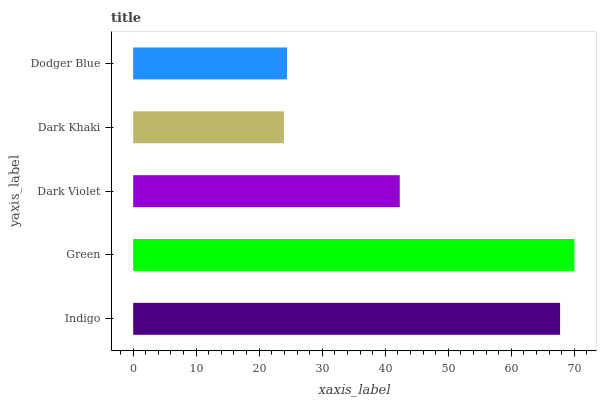Is Dark Khaki the minimum?
Answer yes or no. Yes. Is Green the maximum?
Answer yes or no. Yes. Is Dark Violet the minimum?
Answer yes or no. No. Is Dark Violet the maximum?
Answer yes or no. No. Is Green greater than Dark Violet?
Answer yes or no. Yes. Is Dark Violet less than Green?
Answer yes or no. Yes. Is Dark Violet greater than Green?
Answer yes or no. No. Is Green less than Dark Violet?
Answer yes or no. No. Is Dark Violet the high median?
Answer yes or no. Yes. Is Dark Violet the low median?
Answer yes or no. Yes. Is Indigo the high median?
Answer yes or no. No. Is Dark Khaki the low median?
Answer yes or no. No. 